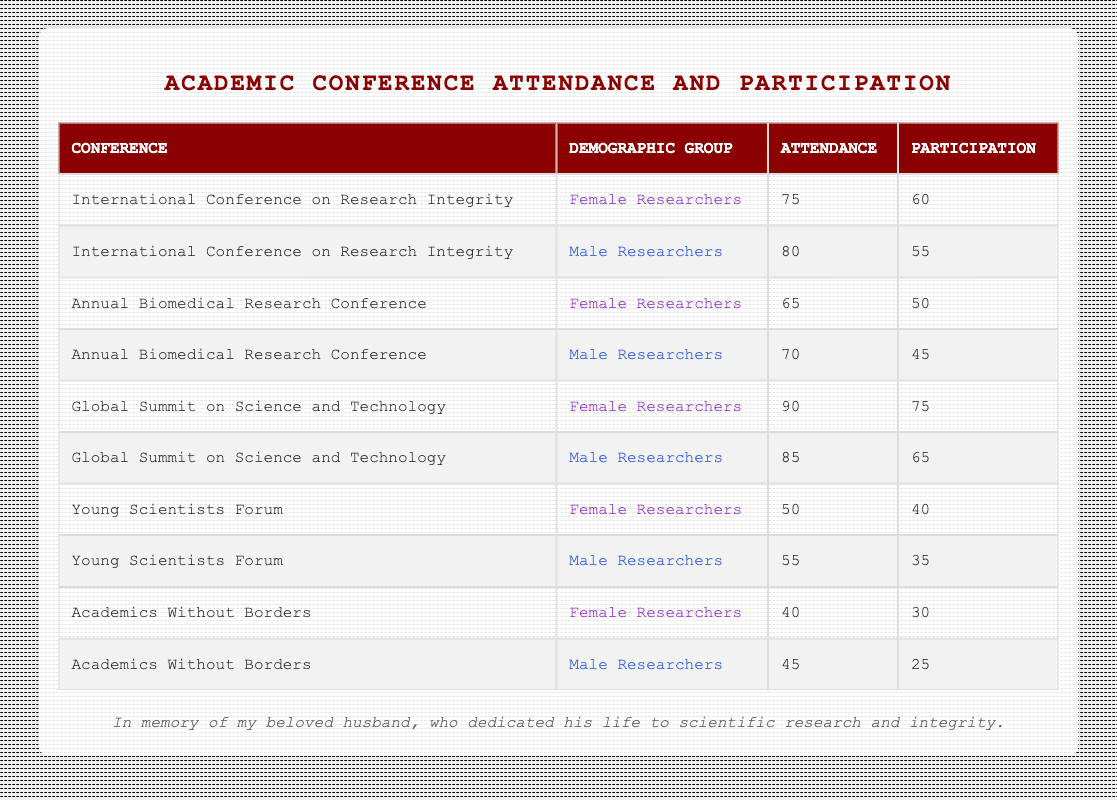What is the attendance of Female Researchers at the Global Summit on Science and Technology? The table indicates that under the "Global Summit on Science and Technology," the attendance for Female Researchers is listed as 90.
Answer: 90 What is the participation rate of Male Researchers in the Young Scientists Forum? According to the table, the participation of Male Researchers at the "Young Scientists Forum" is recorded as 35.
Answer: 35 Which conference had the highest attendance overall? By reviewing the table, the "Global Summit on Science and Technology" shows the highest attendance with a total of 90 for Female Researchers and 85 for Male Researchers, yielding an overall attendance of 175.
Answer: Global Summit on Science and Technology Did more Male Researchers attend the International Conference on Research Integrity than Female Researchers? The table shows that 80 Male Researchers attended while 75 Female Researchers attended, indicating that more Male Researchers indeed attended the conference.
Answer: Yes What is the average participation of Female Researchers across all conferences? The participation numbers for Female Researchers are 60, 50, 75, 40, and 30. Summing these gives 255. There are 5 data points, so the average is 255 / 5 = 51.
Answer: 51 What is the difference in attendance between Male and Female Researchers at the Academics Without Borders conference? For the "Academics Without Borders" conference, Female Researchers had an attendance of 40, while Male Researchers had an attendance of 45. The difference is 45 - 40 = 5.
Answer: 5 What is the total number of participants across all conferences for Male Researchers? By checking the participation of Male Researchers: 55 + 45 + 65 + 35 + 25 = 225. This sum totals to 225 participants across all conferences.
Answer: 225 Which demographic group had a higher overall participation rate, Male or Female Researchers? Total participation for Male Researchers is 55 + 45 + 65 + 35 + 25 = 225, while for Female Researchers it is 60 + 50 + 75 + 40 + 30 = 255. Since 255 is greater than 225, Female Researchers had a higher overall participation rate.
Answer: Female Researchers How many more Female Researchers participated than Male Researchers at the Global Summit on Science and Technology? The Female Researchers had 75 participants while Male Researchers had 65 participants at this conference. The difference is 75 - 65 = 10.
Answer: 10 